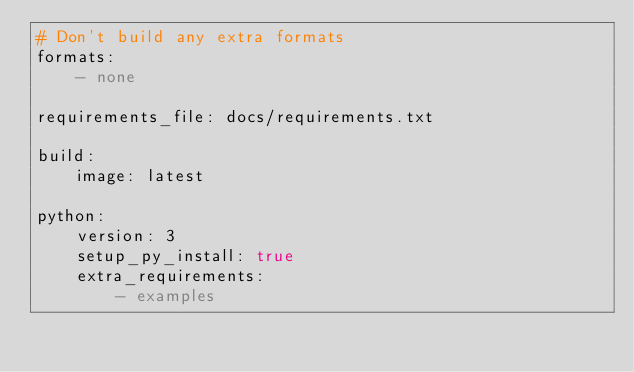<code> <loc_0><loc_0><loc_500><loc_500><_YAML_># Don't build any extra formats
formats:
    - none

requirements_file: docs/requirements.txt

build:
    image: latest

python:
    version: 3
    setup_py_install: true 
    extra_requirements:
        - examples</code> 